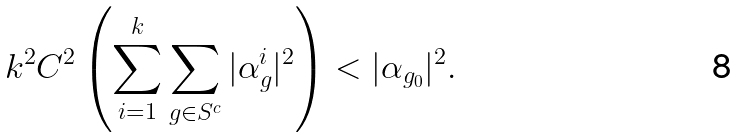<formula> <loc_0><loc_0><loc_500><loc_500>k ^ { 2 } C ^ { 2 } \left ( \sum _ { i = 1 } ^ { k } \sum _ { g \in S ^ { c } } | \alpha _ { g } ^ { i } | ^ { 2 } \right ) < | \alpha _ { g _ { 0 } } | ^ { 2 } .</formula> 